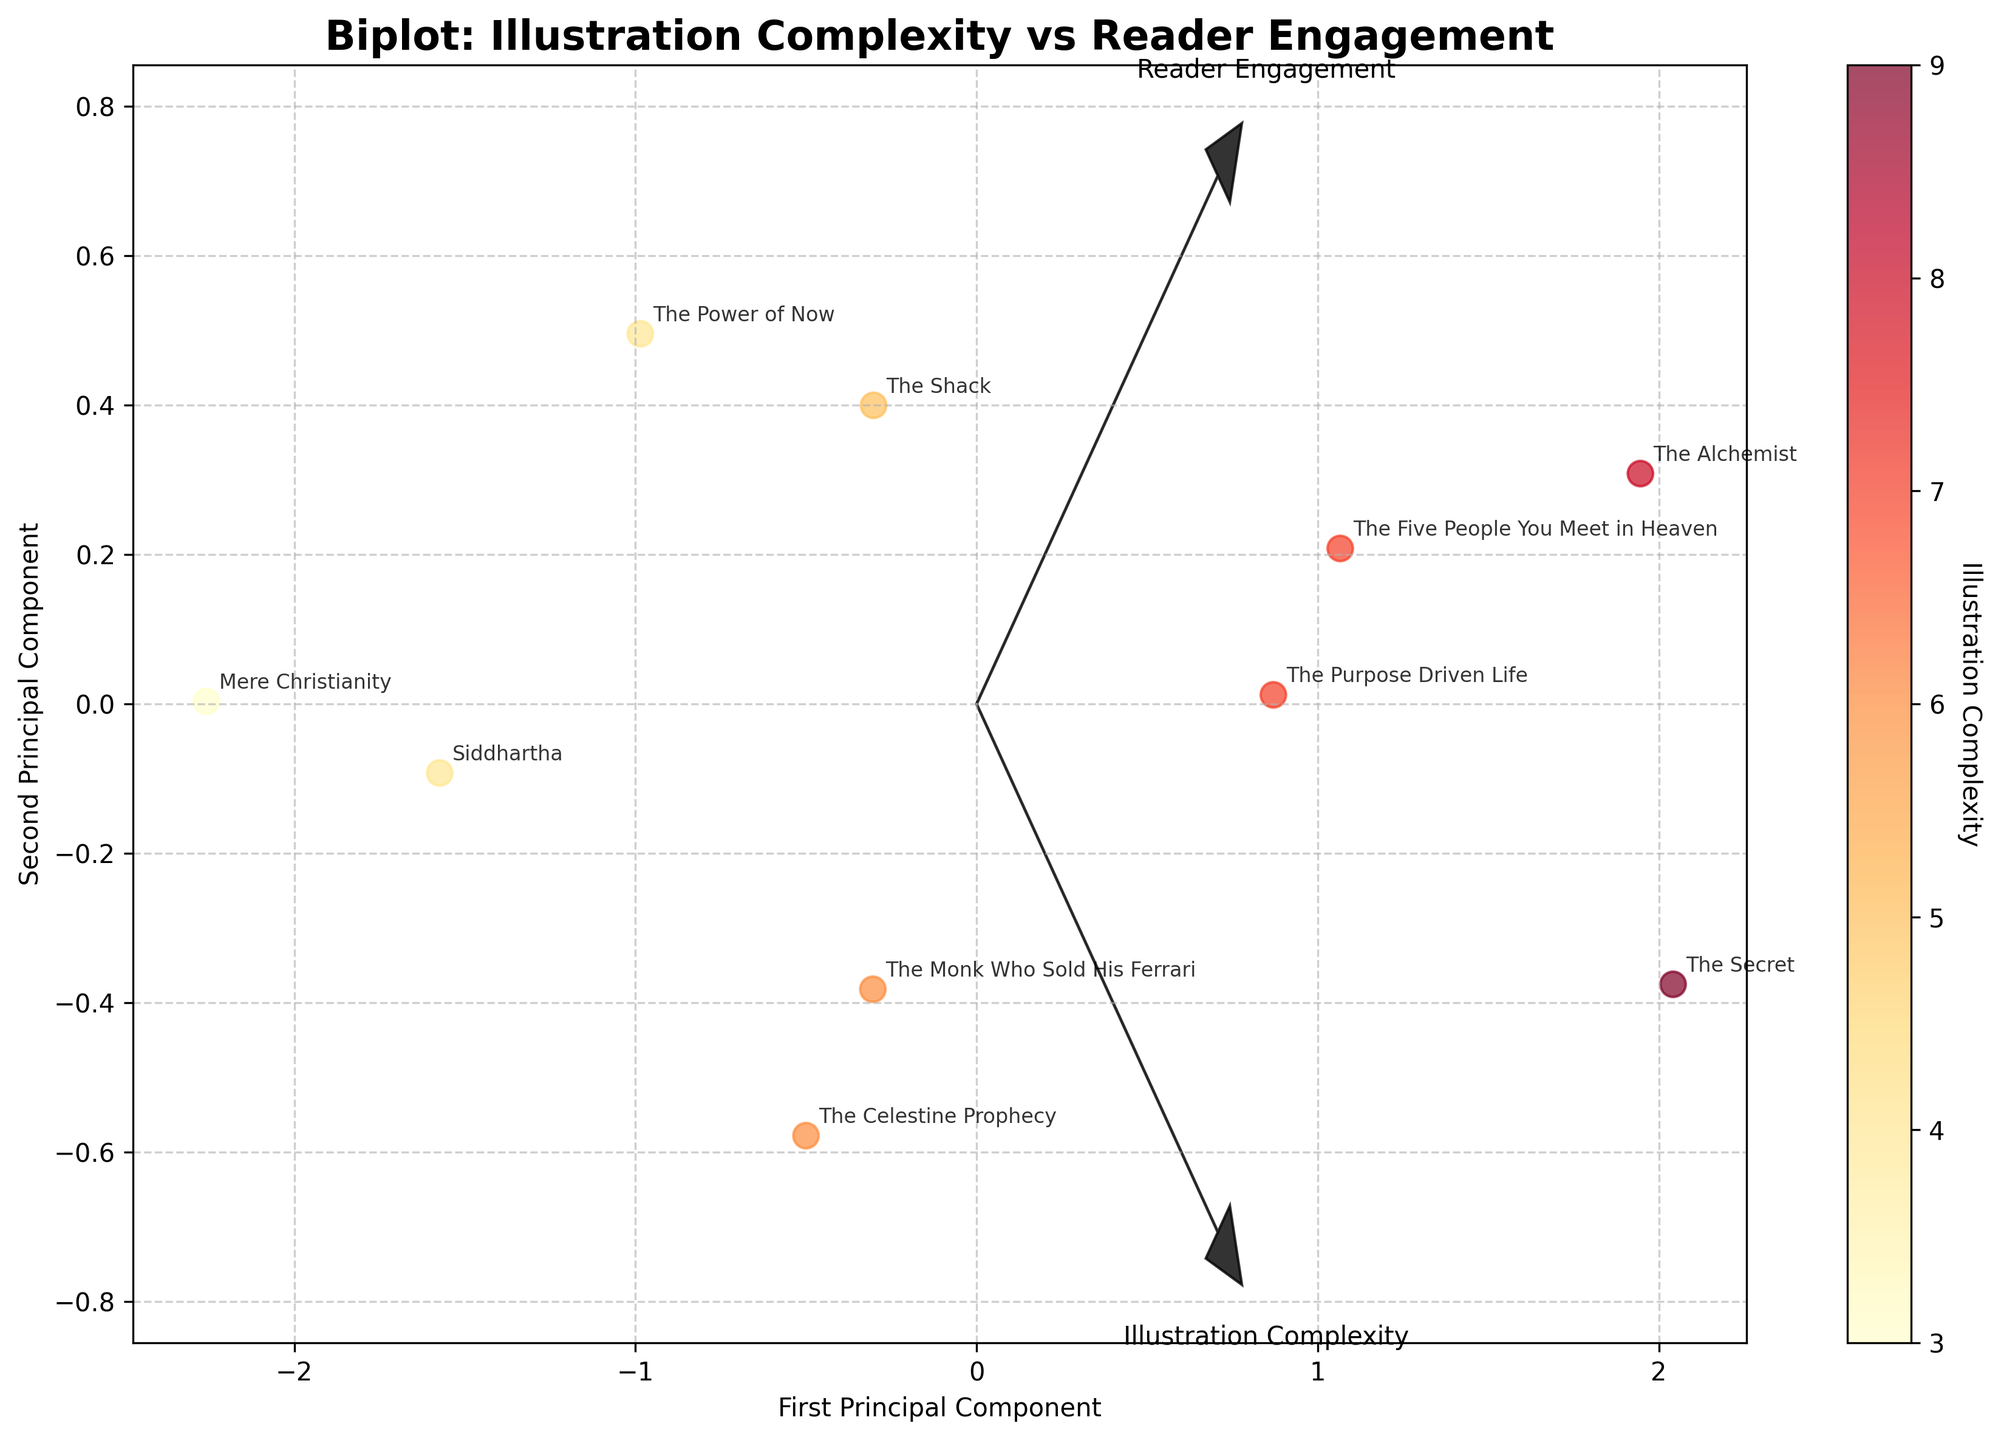What is the title of the figure? The title of the figure is located at the top center, usually in a larger and bold font. In the plot provided, the title reads "Biplot: Illustration Complexity vs Reader Engagement".
Answer: "Biplot: Illustration Complexity vs Reader Engagement" How many books are represented in the figure? The number of books can be determined by counting the data points annotated with book titles in the scatter plot. By examining the plot, there are 10 annotated points with titles.
Answer: 10 Which book has the highest reader engagement? Locate the data point with the highest value along the 'Reader Engagement' axis and look at the annotation. The book "The Alchemist" reaches the highest value of 9.2.
Answer: The Alchemist Which arrow represents 'Illustration Complexity'? There are feature vectors represented by arrows in the plot. By reading the labels at the end of the arrows, the one labeled 'Illustration Complexity' represents it. This arrow points towards the right and slightly upwards.
Answer: The right and slightly upwards arrow Which book has the lowest illustration complexity and what is its reader engagement? Find the data point near the lowest value on the 'Illustration Complexity' axis and check the annotation for its title and reader engagement. "Mere Christianity" has the lowest complexity with a value of 3 and a reader engagement of 6.9.
Answer: Mere Christianity, 6.9 Are there any books with both high illustration complexity and high reader engagement? Look for data points located at high values in both 'Illustration Complexity' and 'Reader Engagement' dimensions. "The Secret" and "The Alchemist" are both positioned in the higher ends of the plot.
Answer: The Secret, The Alchemist Describe the general relationship between illustration complexity and reader engagement shown in the figure. Observing the trend and patterns of data points distribution along the axes can help infer the relationship. The points appear to spread over a positive diagonal line, suggesting that higher illustration complexity tends to associate with higher reader engagement.
Answer: Positive correlation Which book lies closest to the origin (0,0) in the figure? Check for the data point closest to the center of the plot, where both principal components intersect near zero. "Mere Christianity" appears to be nearest to the origin.
Answer: Mere Christianity How do the plotted arrows (feature vectors) help in interpreting the biplot? Feature vectors indicate the direction and magnitude of the variables 'Illustration Complexity' and 'Reader Engagement' on the principal component axes. Their orientation helps understand how each variable influences the data points' placement.
Answer: They show variable influence What colors are used to represent the data points, and what do they signify? The color palette varies from yellow to red in a continuous scale, used to encode 'Illustration Complexity'. The colorbar on the side provides a clue with colors transitioning from lighter to darker shades as complexity increases.
Answer: Yellow to red representing increasing complexity 